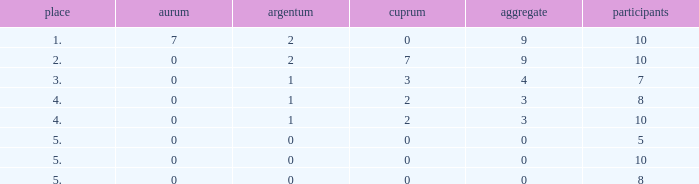Write the full table. {'header': ['place', 'aurum', 'argentum', 'cuprum', 'aggregate', 'participants'], 'rows': [['1.', '7', '2', '0', '9', '10'], ['2.', '0', '2', '7', '9', '10'], ['3.', '0', '1', '3', '4', '7'], ['4.', '0', '1', '2', '3', '8'], ['4.', '0', '1', '2', '3', '10'], ['5.', '0', '0', '0', '0', '5'], ['5.', '0', '0', '0', '0', '10'], ['5.', '0', '0', '0', '0', '8']]} What is the total number of Participants that has Silver that's smaller than 0? None. 